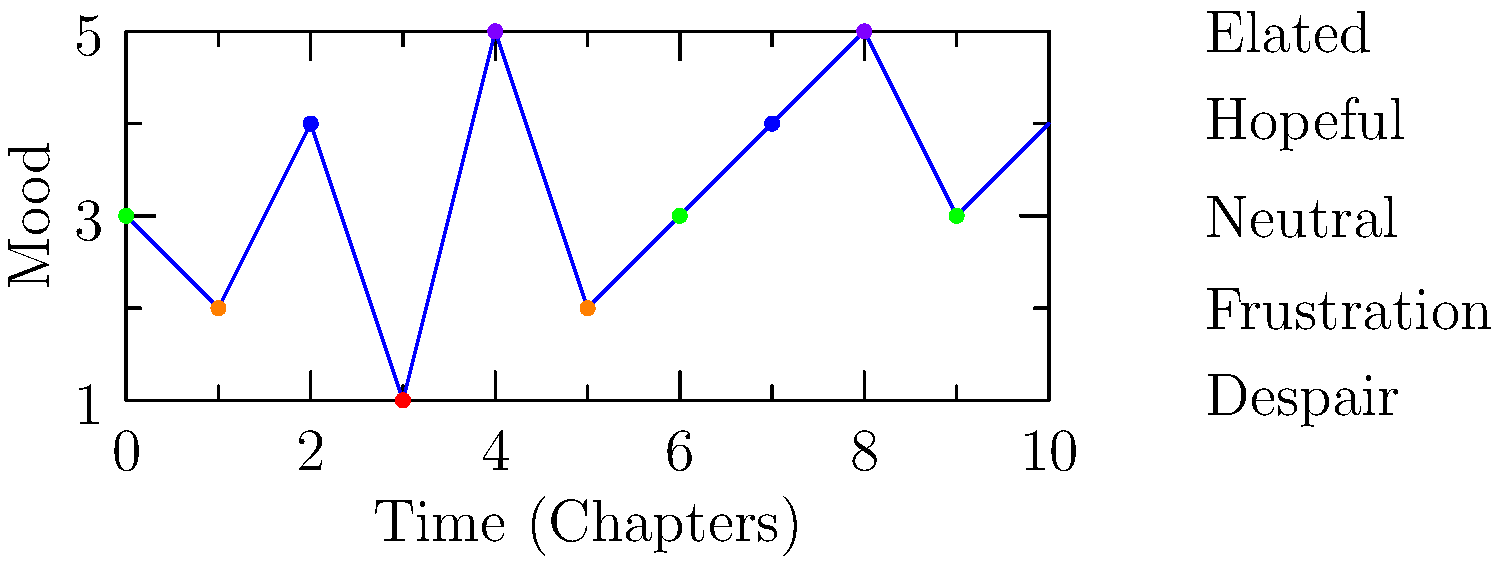Analyze the color-coded mood chart of a protagonist's emotional journey throughout a novel. What significant event likely occurred around chapter 3, and how might this impact the character's development for the rest of the story? To analyze the protagonist's emotional journey and its impact on character development, let's break down the mood chart:

1. The x-axis represents time (chapters), while the y-axis represents mood levels from 1 (Despair) to 5 (Elated).

2. Each dot represents the character's mood at a specific point in the story, color-coded for easy interpretation.

3. At chapter 3, we observe a sharp drop in mood from 4 (Hopeful) to 1 (Despair). This sudden change suggests a significant negative event occurred.

4. The event's impact is evident in the subsequent chapters:
   a. Chapters 4-5 show a rapid increase in mood, possibly indicating resilience or a positive turn of events.
   b. The rest of the chart shows fluctuations between neutral and elated moods, suggesting ongoing challenges and triumphs.

5. The character's development is likely influenced by this chapter 3 event in several ways:
   a. Increased resilience, as shown by the quick recovery in chapters 4-5.
   b. Greater emotional range, evidenced by the varied moods throughout the rest of the story.
   c. Possible character growth from overcoming the significant setback.

6. The overall trend shows an upward trajectory in mood, implying that the character ultimately grows from their experiences.

This analysis suggests that the event in chapter 3 serves as a crucial turning point, catalyzing the protagonist's emotional and personal growth throughout the remainder of the novel.
Answer: A major setback leading to character growth and resilience 